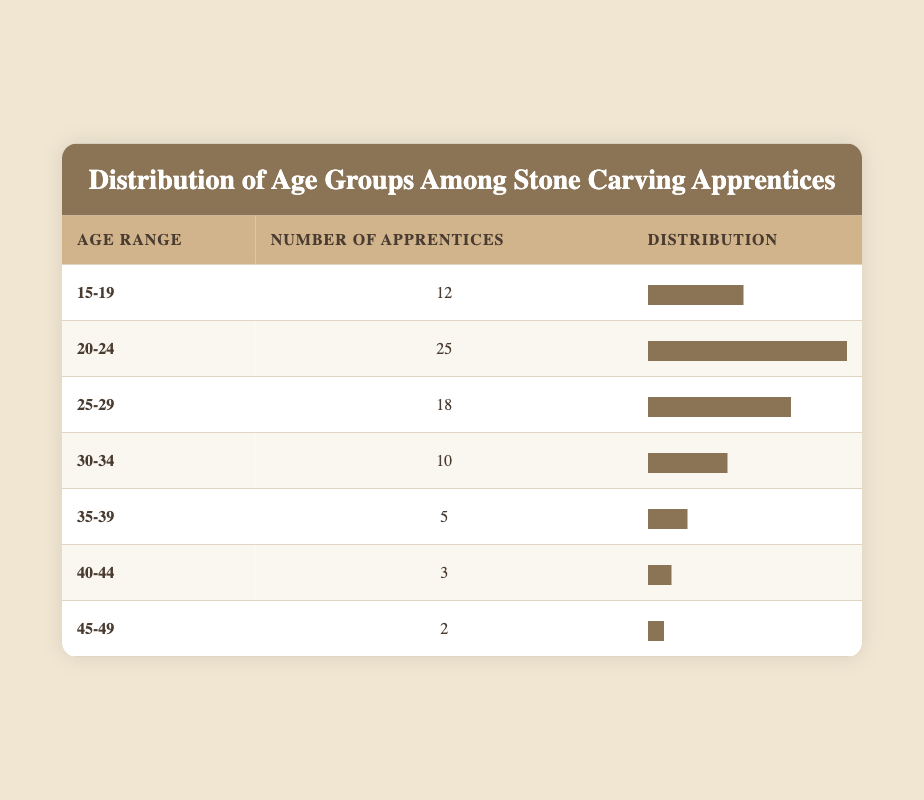What is the age range with the highest number of apprentices? By looking at the table, we see that the age range "20-24" has 25 apprentices, which is higher than any other age range listed.
Answer: 20-24 How many apprentices are there in the age range 30-34? The table directly shows that there are 10 apprentices in the age range of 30-34.
Answer: 10 What is the total number of apprentices across all age groups? To find the total, we sum the number of apprentices for each age range: 12 + 25 + 18 + 10 + 5 + 3 + 2 = 75.
Answer: 75 Is there an age group with less than 5 apprentices? By examining the table, we see that the age groups "40-44" and "45-49" have 3 and 2 apprentices respectively, both of which are less than 5.
Answer: Yes What is the percentage of apprentices aged 25-29 compared to the total number of apprentices? First, we have the number of apprentices aged 25-29, which is 18. The total number of apprentices is 75. The percentage is calculated as (18 / 75) * 100 = 24%.
Answer: 24% How many more apprentices are there in the age range 20-24 than in the age range 15-19? From the table, we take the values for the two age ranges: 20-24 has 25 apprentices and 15-19 has 12. The difference is 25 - 12 = 13 apprentices.
Answer: 13 What is the average number of apprentices across all age groups? To find the average, we divide the total number of apprentices, which is 75, by the number of age groups listed, which is 7. Thus, the average is 75 / 7 ≈ 10.71.
Answer: 10.71 Which age range has the lowest number of apprentices? According to the table, the age range "45-49" has the lowest number of apprentices at 2.
Answer: 45-49 What is the total number of apprentices aged 35 and older? We add the number of apprentices in the age ranges 35-39, 40-44, and 45-49: 5 + 3 + 2 = 10.
Answer: 10 